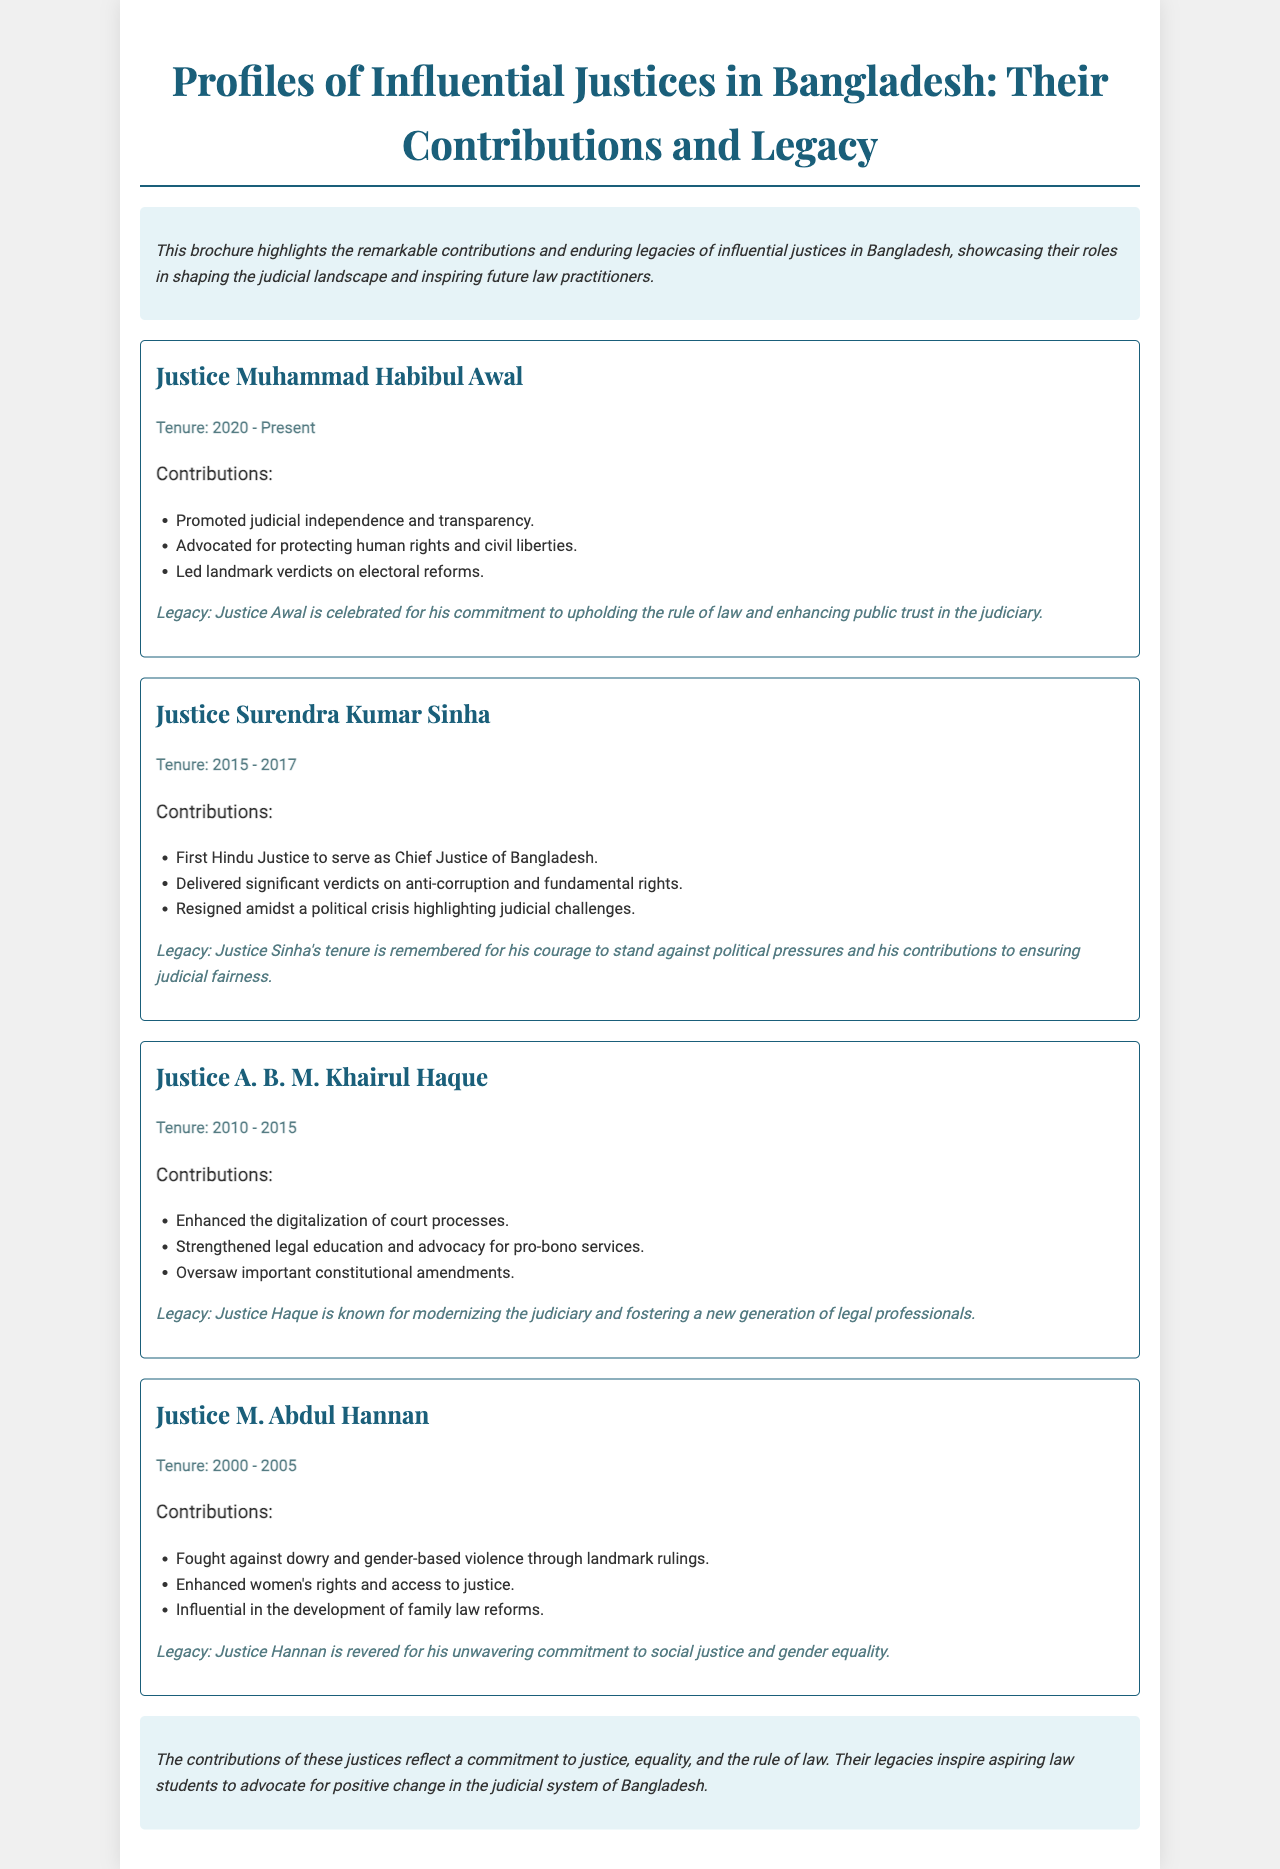What is the title of the brochure? The title of the brochure is prominently displayed at the top of the document.
Answer: Profiles of Influential Justices in Bangladesh: Their Contributions and Legacy Who is the current justice mentioned in the document? The document lists justices along with their tenure, with one currently in office.
Answer: Justice Muhammad Habibul Awal What is the tenure of Justice Surendra Kumar Sinha? His tenure is mentioned specifically in the document.
Answer: 2015 - 2017 Which justice is known for modernizing the judiciary? The legacy of a particular justice highlights his contributions to modernizing the judiciary.
Answer: Justice A. B. M. Khairul Haque What landmark issue did Justice M. Abdul Hannan address? The contributions section mentions his focus on a specific social justice issue.
Answer: Gender-based violence What is a common theme in the legacies of these justices? The legacies of the justices reflect recurring themes discussed in the document.
Answer: Commitment to justice How is the document structured? The document is organized to present profiles of justices, with headings for each section.
Answer: Profiles of justices Which justice was the first Hindu to serve as Chief Justice? This information is highlighted in the contributions of a particular justice.
Answer: Justice Surendra Kumar Sinha 